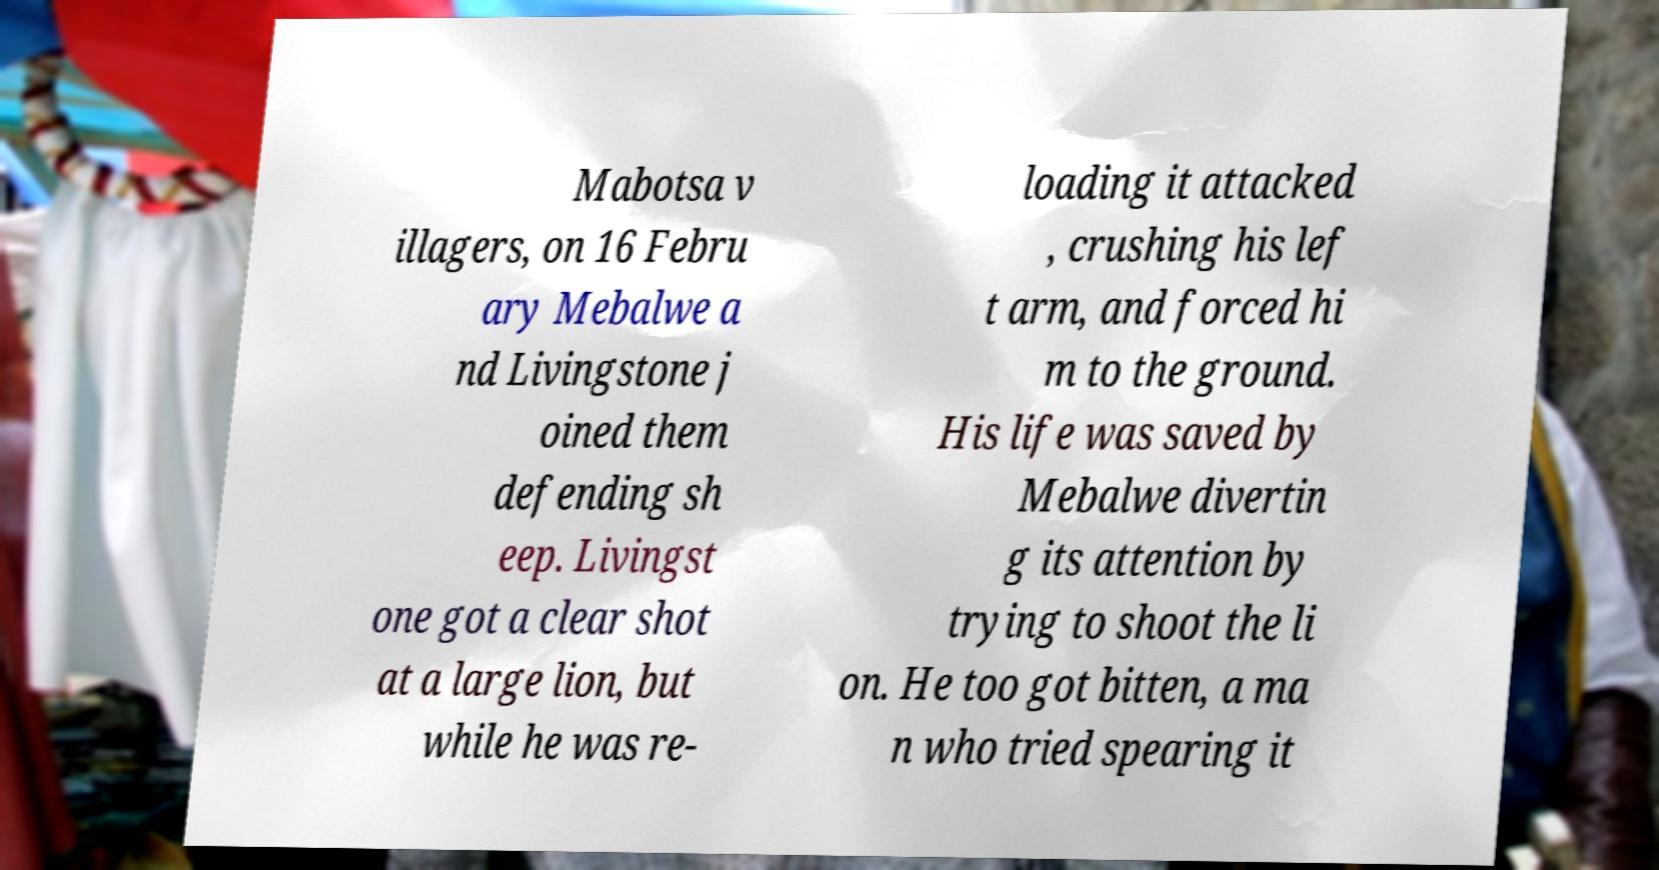What messages or text are displayed in this image? I need them in a readable, typed format. Mabotsa v illagers, on 16 Febru ary Mebalwe a nd Livingstone j oined them defending sh eep. Livingst one got a clear shot at a large lion, but while he was re- loading it attacked , crushing his lef t arm, and forced hi m to the ground. His life was saved by Mebalwe divertin g its attention by trying to shoot the li on. He too got bitten, a ma n who tried spearing it 